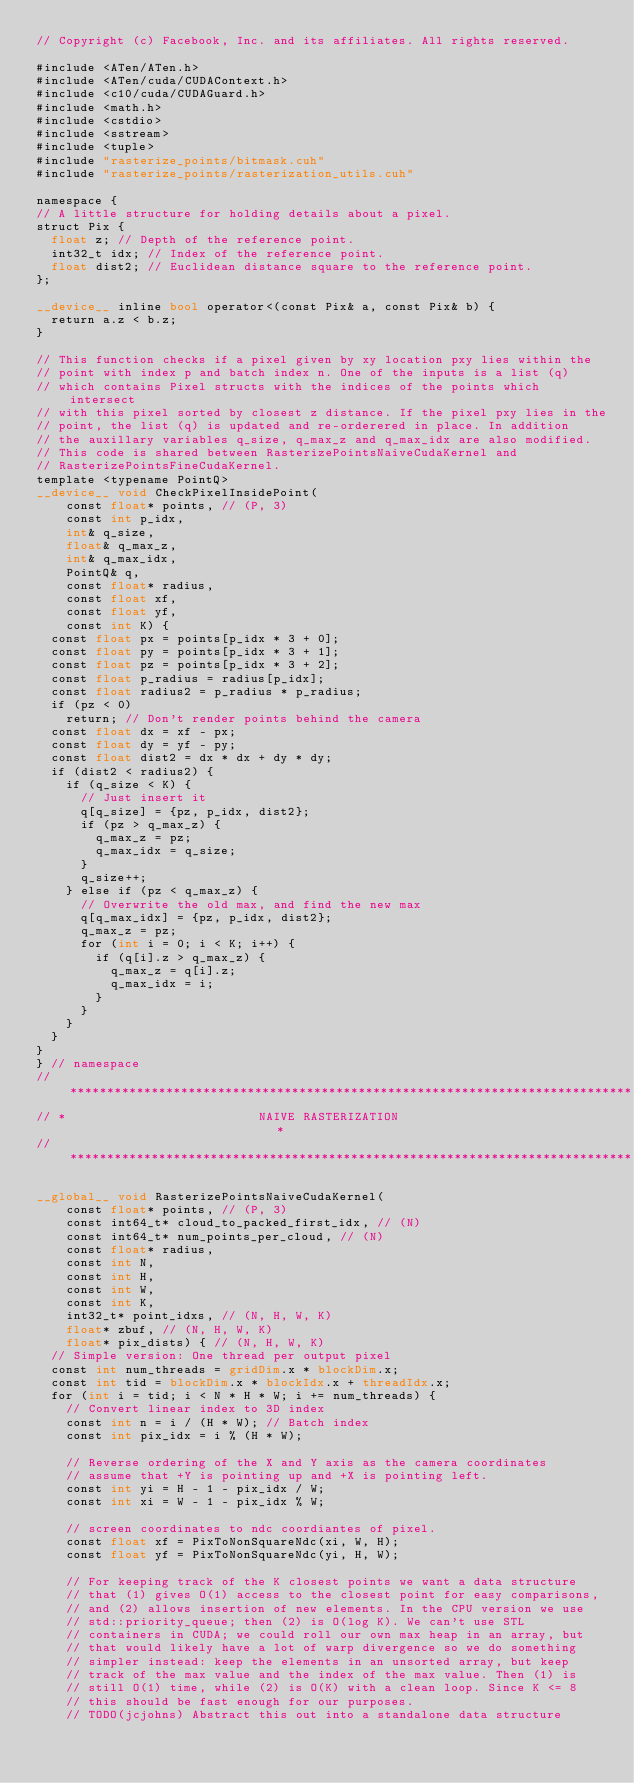<code> <loc_0><loc_0><loc_500><loc_500><_Cuda_>// Copyright (c) Facebook, Inc. and its affiliates. All rights reserved.

#include <ATen/ATen.h>
#include <ATen/cuda/CUDAContext.h>
#include <c10/cuda/CUDAGuard.h>
#include <math.h>
#include <cstdio>
#include <sstream>
#include <tuple>
#include "rasterize_points/bitmask.cuh"
#include "rasterize_points/rasterization_utils.cuh"

namespace {
// A little structure for holding details about a pixel.
struct Pix {
  float z; // Depth of the reference point.
  int32_t idx; // Index of the reference point.
  float dist2; // Euclidean distance square to the reference point.
};

__device__ inline bool operator<(const Pix& a, const Pix& b) {
  return a.z < b.z;
}

// This function checks if a pixel given by xy location pxy lies within the
// point with index p and batch index n. One of the inputs is a list (q)
// which contains Pixel structs with the indices of the points which intersect
// with this pixel sorted by closest z distance. If the pixel pxy lies in the
// point, the list (q) is updated and re-orderered in place. In addition
// the auxillary variables q_size, q_max_z and q_max_idx are also modified.
// This code is shared between RasterizePointsNaiveCudaKernel and
// RasterizePointsFineCudaKernel.
template <typename PointQ>
__device__ void CheckPixelInsidePoint(
    const float* points, // (P, 3)
    const int p_idx,
    int& q_size,
    float& q_max_z,
    int& q_max_idx,
    PointQ& q,
    const float* radius,
    const float xf,
    const float yf,
    const int K) {
  const float px = points[p_idx * 3 + 0];
  const float py = points[p_idx * 3 + 1];
  const float pz = points[p_idx * 3 + 2];
  const float p_radius = radius[p_idx];
  const float radius2 = p_radius * p_radius;
  if (pz < 0)
    return; // Don't render points behind the camera
  const float dx = xf - px;
  const float dy = yf - py;
  const float dist2 = dx * dx + dy * dy;
  if (dist2 < radius2) {
    if (q_size < K) {
      // Just insert it
      q[q_size] = {pz, p_idx, dist2};
      if (pz > q_max_z) {
        q_max_z = pz;
        q_max_idx = q_size;
      }
      q_size++;
    } else if (pz < q_max_z) {
      // Overwrite the old max, and find the new max
      q[q_max_idx] = {pz, p_idx, dist2};
      q_max_z = pz;
      for (int i = 0; i < K; i++) {
        if (q[i].z > q_max_z) {
          q_max_z = q[i].z;
          q_max_idx = i;
        }
      }
    }
  }
}
} // namespace
// ****************************************************************************
// *                          NAIVE RASTERIZATION                             *
// ****************************************************************************

__global__ void RasterizePointsNaiveCudaKernel(
    const float* points, // (P, 3)
    const int64_t* cloud_to_packed_first_idx, // (N)
    const int64_t* num_points_per_cloud, // (N)
    const float* radius,
    const int N,
    const int H,
    const int W,
    const int K,
    int32_t* point_idxs, // (N, H, W, K)
    float* zbuf, // (N, H, W, K)
    float* pix_dists) { // (N, H, W, K)
  // Simple version: One thread per output pixel
  const int num_threads = gridDim.x * blockDim.x;
  const int tid = blockDim.x * blockIdx.x + threadIdx.x;
  for (int i = tid; i < N * H * W; i += num_threads) {
    // Convert linear index to 3D index
    const int n = i / (H * W); // Batch index
    const int pix_idx = i % (H * W);

    // Reverse ordering of the X and Y axis as the camera coordinates
    // assume that +Y is pointing up and +X is pointing left.
    const int yi = H - 1 - pix_idx / W;
    const int xi = W - 1 - pix_idx % W;

    // screen coordinates to ndc coordiantes of pixel.
    const float xf = PixToNonSquareNdc(xi, W, H);
    const float yf = PixToNonSquareNdc(yi, H, W);

    // For keeping track of the K closest points we want a data structure
    // that (1) gives O(1) access to the closest point for easy comparisons,
    // and (2) allows insertion of new elements. In the CPU version we use
    // std::priority_queue; then (2) is O(log K). We can't use STL
    // containers in CUDA; we could roll our own max heap in an array, but
    // that would likely have a lot of warp divergence so we do something
    // simpler instead: keep the elements in an unsorted array, but keep
    // track of the max value and the index of the max value. Then (1) is
    // still O(1) time, while (2) is O(K) with a clean loop. Since K <= 8
    // this should be fast enough for our purposes.
    // TODO(jcjohns) Abstract this out into a standalone data structure</code> 